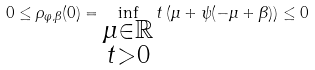Convert formula to latex. <formula><loc_0><loc_0><loc_500><loc_500>0 \leq \rho _ { \varphi , \beta } ( 0 ) = \inf _ { \substack { \mu \in \mathbb { R } \\ t > 0 } } t \left ( \mu + \psi ( - \mu + \beta ) \right ) \leq 0</formula> 